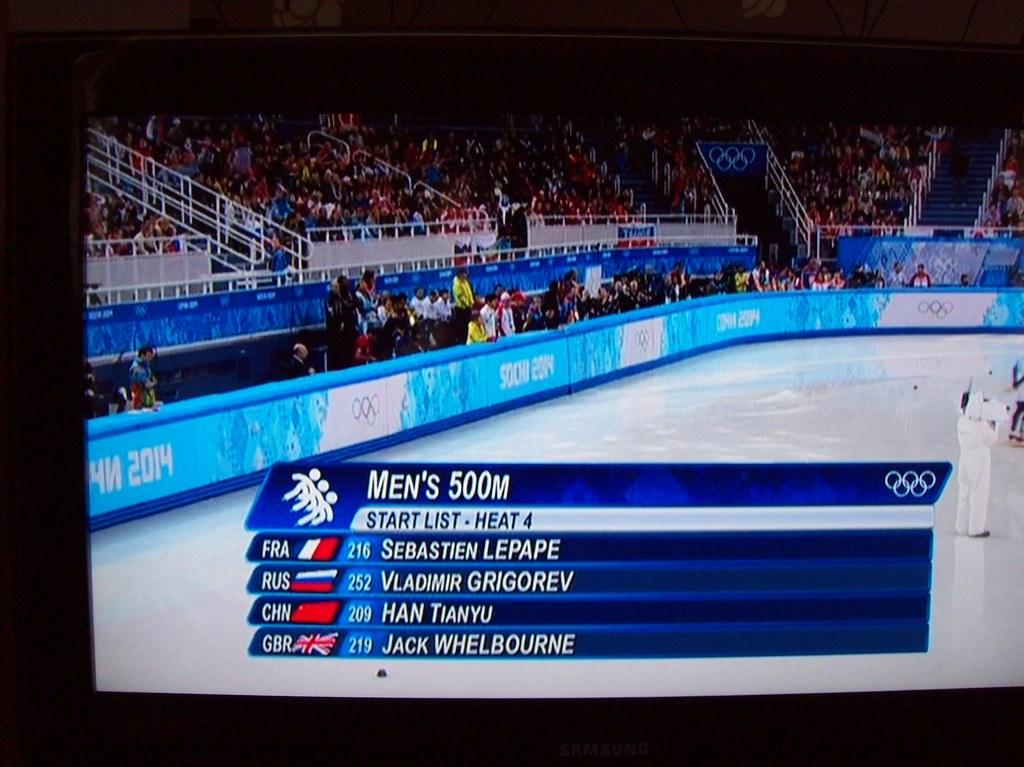<image>
Summarize the visual content of the image. Several athletes names are next to their scores/times for the men's 500m on a screen with an ice arena in the background surrounded with the Olympic symbol. 